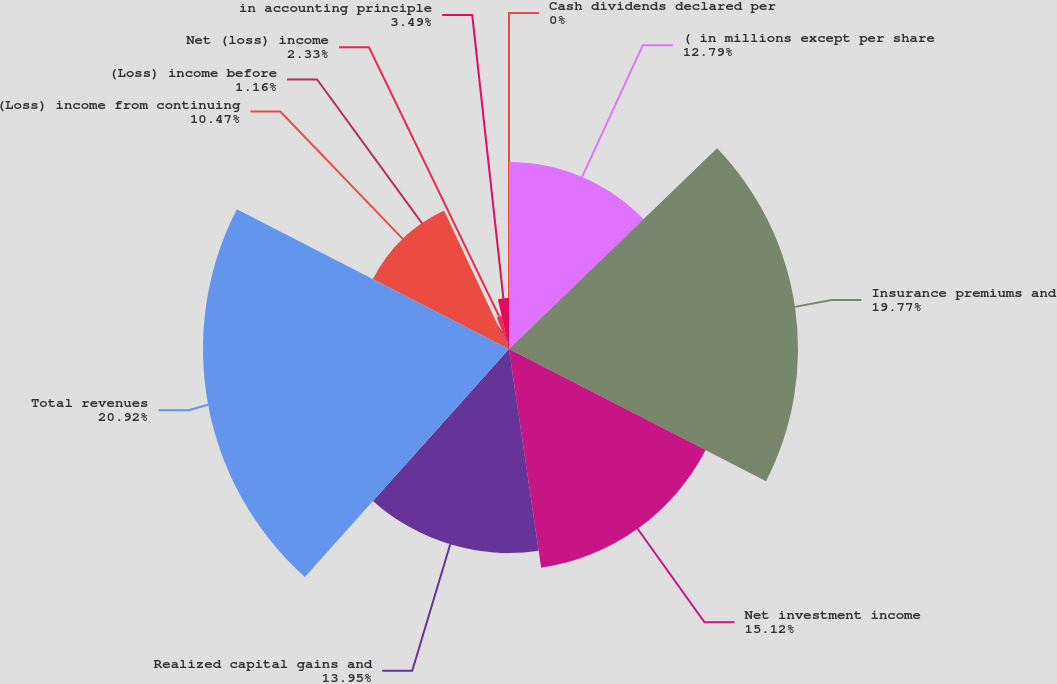Convert chart to OTSL. <chart><loc_0><loc_0><loc_500><loc_500><pie_chart><fcel>( in millions except per share<fcel>Insurance premiums and<fcel>Net investment income<fcel>Realized capital gains and<fcel>Total revenues<fcel>(Loss) income from continuing<fcel>(Loss) income before<fcel>Net (loss) income<fcel>in accounting principle<fcel>Cash dividends declared per<nl><fcel>12.79%<fcel>19.77%<fcel>15.12%<fcel>13.95%<fcel>20.93%<fcel>10.47%<fcel>1.16%<fcel>2.33%<fcel>3.49%<fcel>0.0%<nl></chart> 